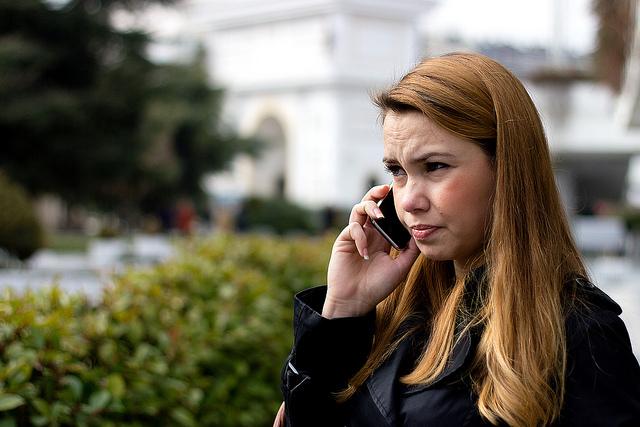What is the women doing?
Keep it brief. Talking on phone. Does the woman look happy?
Be succinct. No. What is the lady talking on?
Concise answer only. Cell phone. Is this person being berated over the phone?
Short answer required. Yes. What color is the girls hair?
Write a very short answer. Red. What color is her hair?
Concise answer only. Light brown. Is she holding her phone in her hand?
Be succinct. Yes. Does this woman wear glasses?
Short answer required. No. 